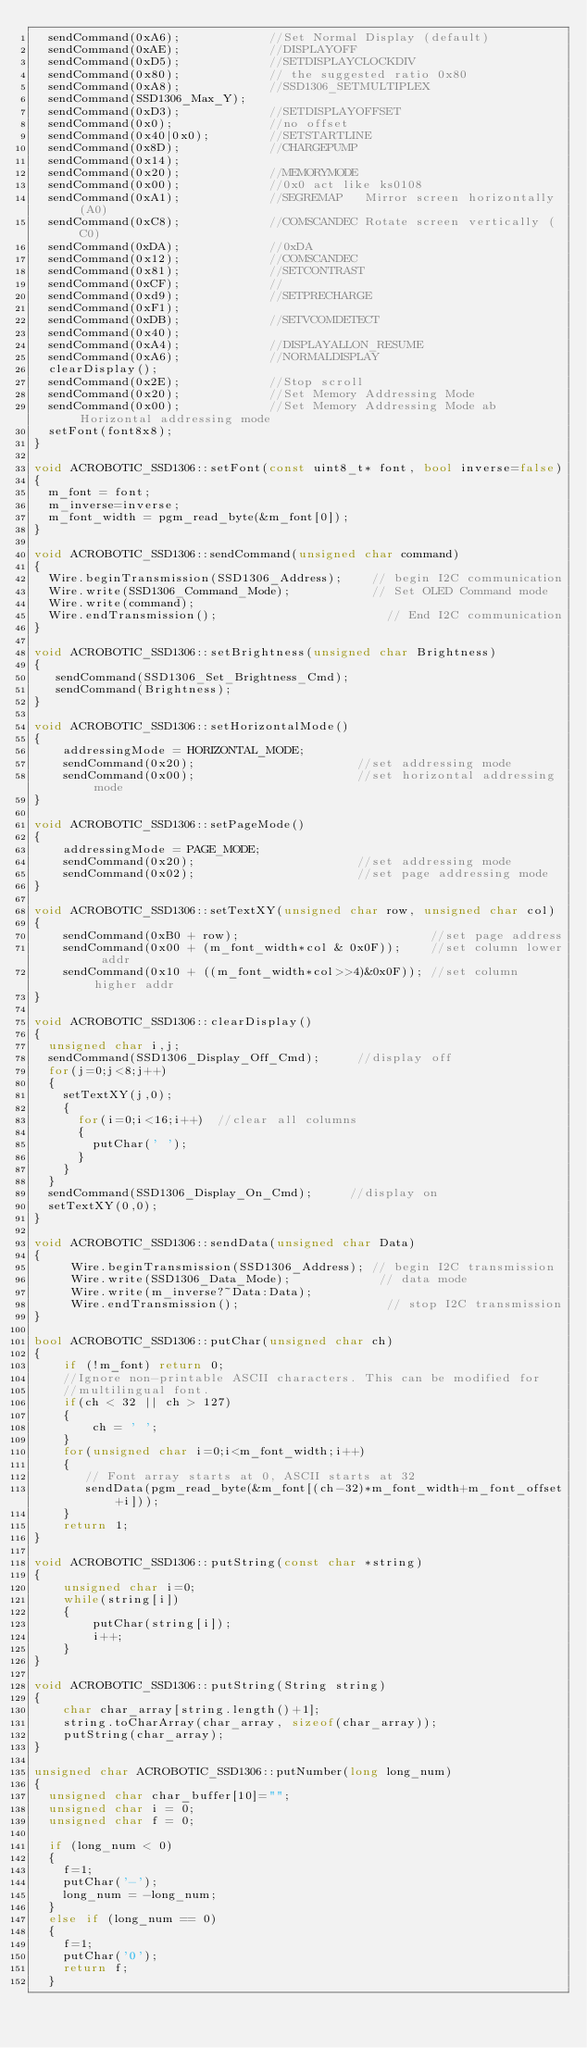Convert code to text. <code><loc_0><loc_0><loc_500><loc_500><_C++_>  sendCommand(0xA6);            //Set Normal Display (default)
  sendCommand(0xAE);            //DISPLAYOFF
  sendCommand(0xD5);            //SETDISPLAYCLOCKDIV
  sendCommand(0x80);            // the suggested ratio 0x80
  sendCommand(0xA8);            //SSD1306_SETMULTIPLEX
  sendCommand(SSD1306_Max_Y);
  sendCommand(0xD3);            //SETDISPLAYOFFSET
  sendCommand(0x0);             //no offset
  sendCommand(0x40|0x0);        //SETSTARTLINE
  sendCommand(0x8D);            //CHARGEPUMP
  sendCommand(0x14);
  sendCommand(0x20);            //MEMORYMODE
  sendCommand(0x00);            //0x0 act like ks0108
  sendCommand(0xA1);            //SEGREMAP   Mirror screen horizontally (A0)
  sendCommand(0xC8);            //COMSCANDEC Rotate screen vertically (C0)
  sendCommand(0xDA);            //0xDA
  sendCommand(0x12);            //COMSCANDEC
  sendCommand(0x81);            //SETCONTRAST
  sendCommand(0xCF);            //
  sendCommand(0xd9);            //SETPRECHARGE 
  sendCommand(0xF1); 
  sendCommand(0xDB);            //SETVCOMDETECT                
  sendCommand(0x40);
  sendCommand(0xA4);            //DISPLAYALLON_RESUME        
  sendCommand(0xA6);            //NORMALDISPLAY             
  clearDisplay();
  sendCommand(0x2E);            //Stop scroll
  sendCommand(0x20);            //Set Memory Addressing Mode
  sendCommand(0x00);            //Set Memory Addressing Mode ab Horizontal addressing mode
  setFont(font8x8);
}

void ACROBOTIC_SSD1306::setFont(const uint8_t* font, bool inverse=false)
{
  m_font = font;
  m_inverse=inverse;
  m_font_width = pgm_read_byte(&m_font[0]);
}

void ACROBOTIC_SSD1306::sendCommand(unsigned char command)
{
  Wire.beginTransmission(SSD1306_Address);    // begin I2C communication
  Wire.write(SSD1306_Command_Mode);           // Set OLED Command mode
  Wire.write(command);
  Wire.endTransmission();                       // End I2C communication
}

void ACROBOTIC_SSD1306::setBrightness(unsigned char Brightness)
{
   sendCommand(SSD1306_Set_Brightness_Cmd);
   sendCommand(Brightness);
}

void ACROBOTIC_SSD1306::setHorizontalMode()
{
    addressingMode = HORIZONTAL_MODE;
    sendCommand(0x20);                      //set addressing mode
    sendCommand(0x00);                      //set horizontal addressing mode
}

void ACROBOTIC_SSD1306::setPageMode()
{
    addressingMode = PAGE_MODE;
    sendCommand(0x20);                      //set addressing mode
    sendCommand(0x02);                      //set page addressing mode
}

void ACROBOTIC_SSD1306::setTextXY(unsigned char row, unsigned char col)
{
    sendCommand(0xB0 + row);                          //set page address
    sendCommand(0x00 + (m_font_width*col & 0x0F));    //set column lower addr
    sendCommand(0x10 + ((m_font_width*col>>4)&0x0F)); //set column higher addr
}

void ACROBOTIC_SSD1306::clearDisplay()
{
  unsigned char i,j;
  sendCommand(SSD1306_Display_Off_Cmd);     //display off
  for(j=0;j<8;j++)
  {    
    setTextXY(j,0);    
    {
      for(i=0;i<16;i++)  //clear all columns
      {
        putChar(' ');    
      }
    }
  }
  sendCommand(SSD1306_Display_On_Cmd);     //display on
  setTextXY(0,0);    
}

void ACROBOTIC_SSD1306::sendData(unsigned char Data)
{
     Wire.beginTransmission(SSD1306_Address); // begin I2C transmission
     Wire.write(SSD1306_Data_Mode);            // data mode
     Wire.write(m_inverse?~Data:Data);
     Wire.endTransmission();                    // stop I2C transmission
}

bool ACROBOTIC_SSD1306::putChar(unsigned char ch)
{
    if (!m_font) return 0;
    //Ignore non-printable ASCII characters. This can be modified for
    //multilingual font.  
    if(ch < 32 || ch > 127) 
    {
        ch = ' ';
    }    
    for(unsigned char i=0;i<m_font_width;i++)
    {
       // Font array starts at 0, ASCII starts at 32
       sendData(pgm_read_byte(&m_font[(ch-32)*m_font_width+m_font_offset+i])); 
    }
    return 1;
}

void ACROBOTIC_SSD1306::putString(const char *string)
{
    unsigned char i=0;
    while(string[i])
    {
        putChar(string[i]);     
        i++;
    }
}

void ACROBOTIC_SSD1306::putString(String string)
{
    char char_array[string.length()+1];
    string.toCharArray(char_array, sizeof(char_array));
    putString(char_array);
}

unsigned char ACROBOTIC_SSD1306::putNumber(long long_num)
{
  unsigned char char_buffer[10]="";
  unsigned char i = 0;
  unsigned char f = 0;

  if (long_num < 0) 
  {
    f=1;
    putChar('-');
    long_num = -long_num;
  } 
  else if (long_num == 0) 
  {
    f=1;
    putChar('0');
    return f;
  } 
</code> 